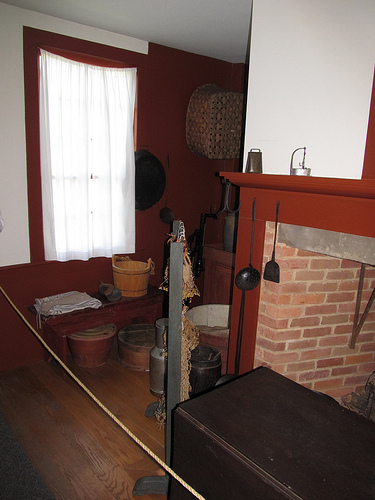Can you describe the items hanged on the wooden beam? Certainly! Hanging from the wooden beam are a variety of cooking utensils traditionally used in open-hearth cooking. These include what appear to be a cast iron skillet, a long-handled frying pan, and several pots of different sizes, adding a functional yet historical charm to the room. Do these items seem merely decorative or functional? Given their prominent placement and how well-maintained they appear, these items could serve both decorative and functional purposes, suggesting a blend of aesthetic intention and practical use. 